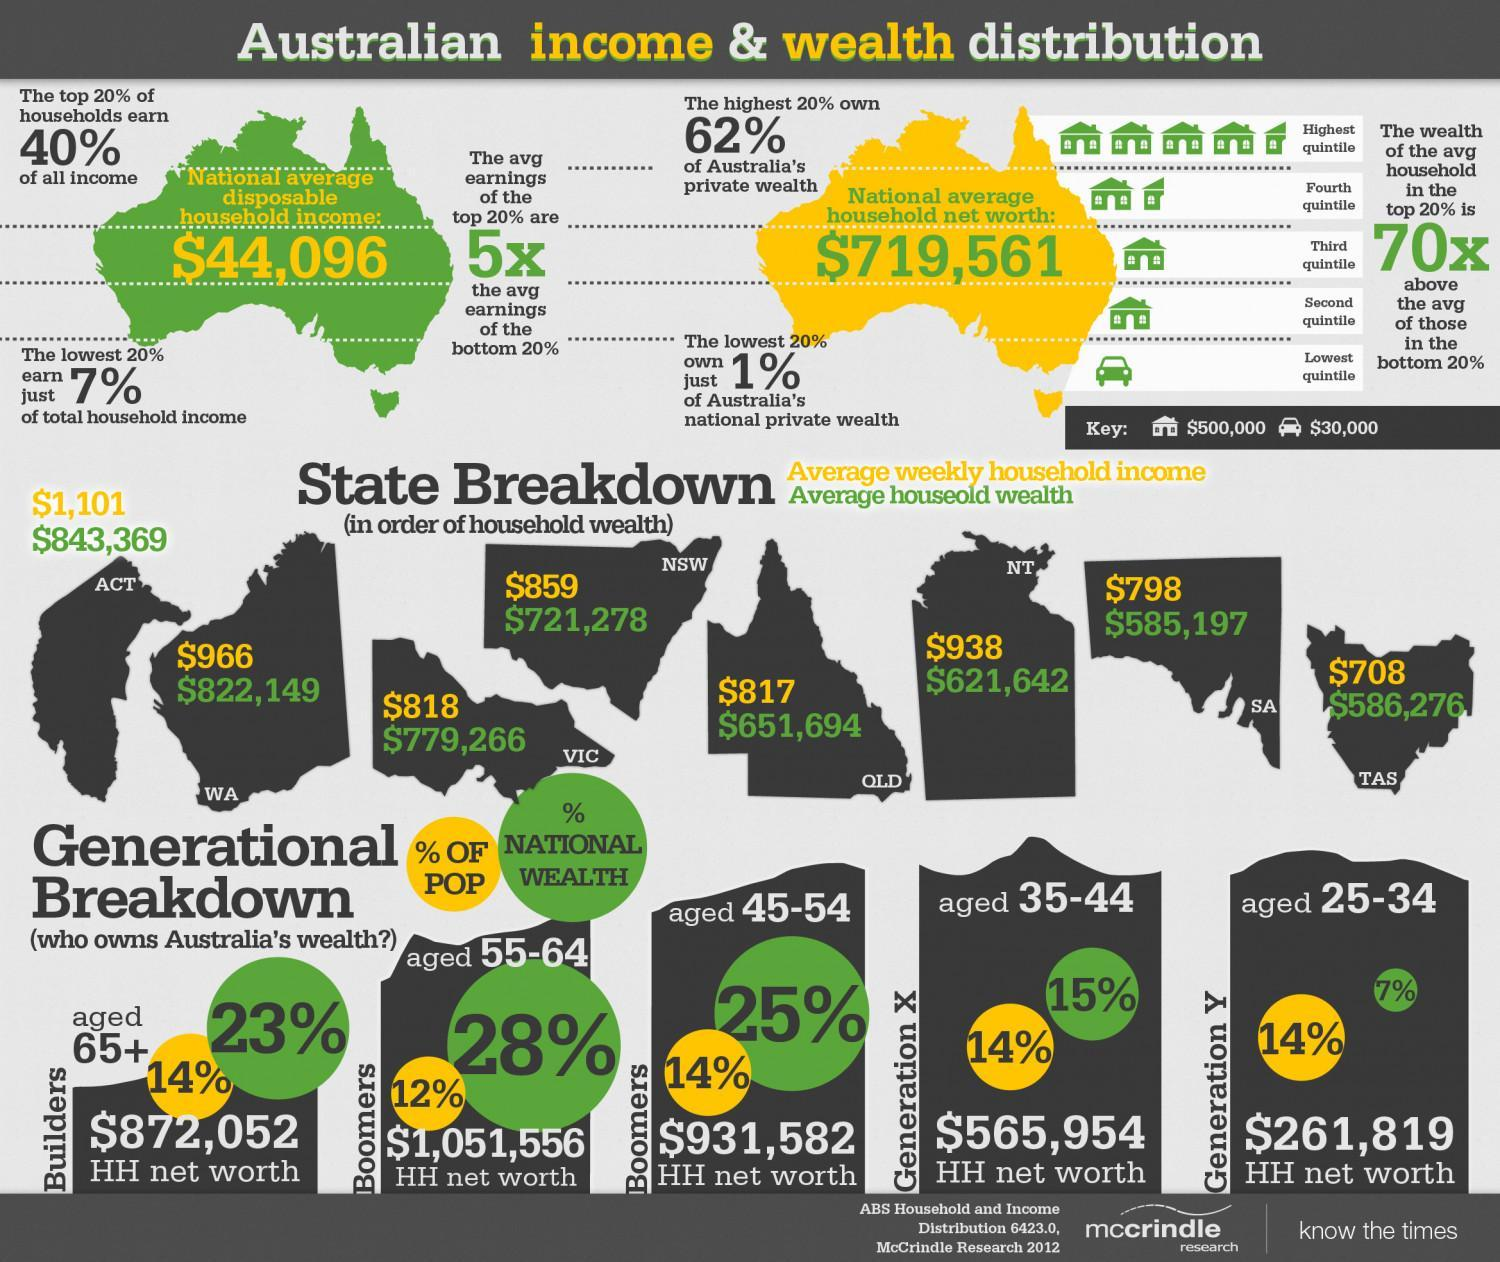What is the percentage of POP of Generation Y?
Answer the question with a short phrase. 14% What is the net percentage of National Wealth of Boomers aged 45-64? 53% What is the percentage of National wealth of Generation Y? 7% What is the percentage of POP of Builders? 14% What is the percentage of National wealth of Builders? 23% What is the percentage of POP of Generation X? 14% What is the HH net worth of Generation X? $565,954 What is the HH net worth of Builders? $872,052 What is the HH net worth of Boomers aged 45-64? $1,983,138 What is the HH net worth of Generation Y? $261,819 What is the percentage of National wealth of Generation X? 15% What is the HH net worth of people aged 25-44? 827,773 